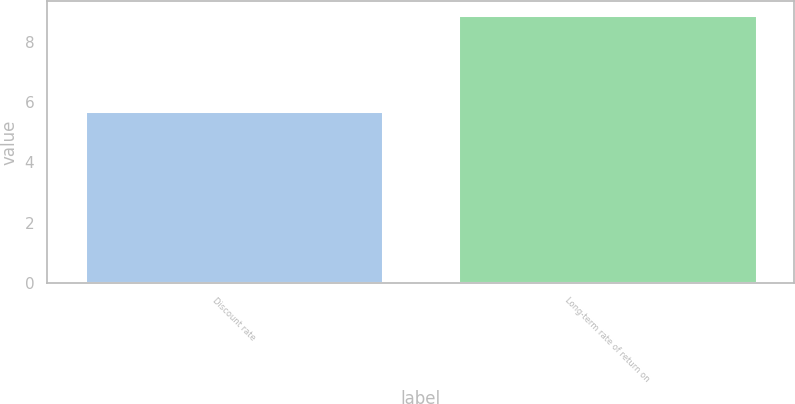<chart> <loc_0><loc_0><loc_500><loc_500><bar_chart><fcel>Discount rate<fcel>Long-term rate of return on<nl><fcel>5.7<fcel>8.9<nl></chart> 